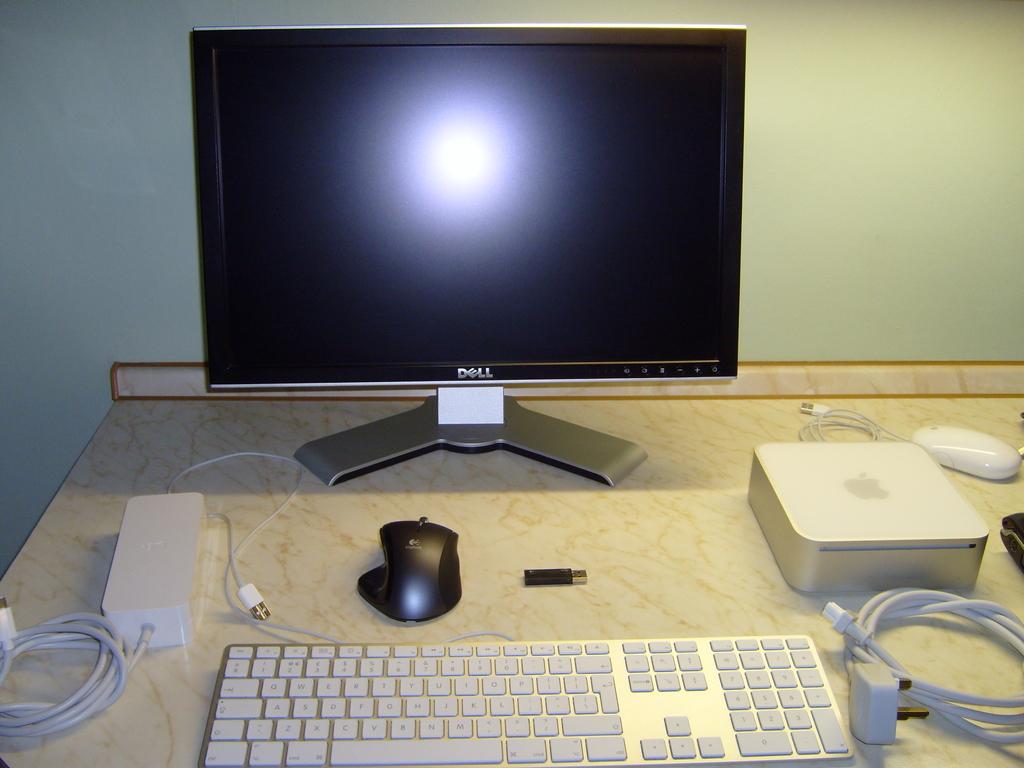What kind of monitor is it?
Keep it short and to the point. Dell. 